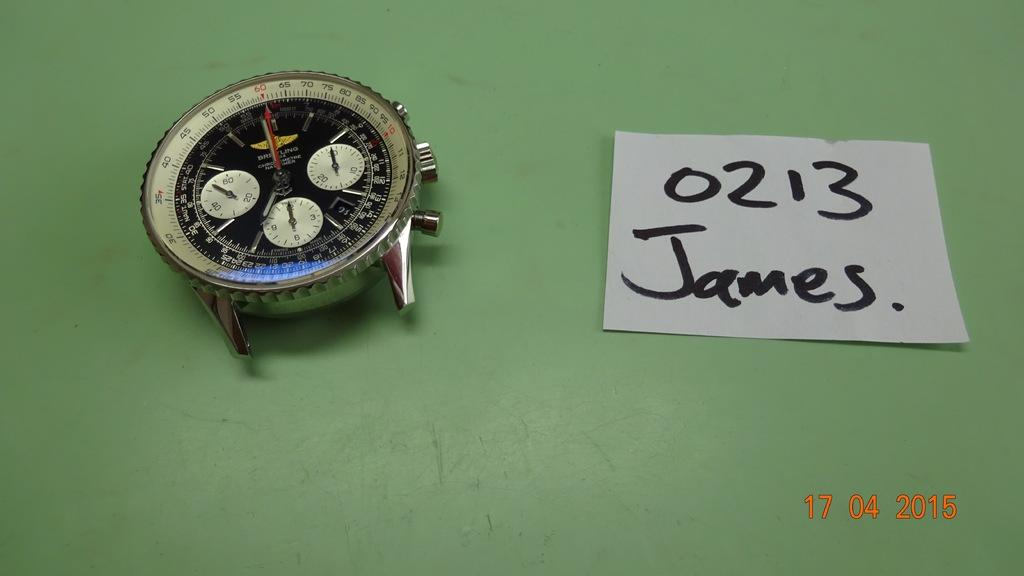Provide a one-sentence caption for the provided image. A watch face on a green counter and a note beside it with 0213 James written on it. 